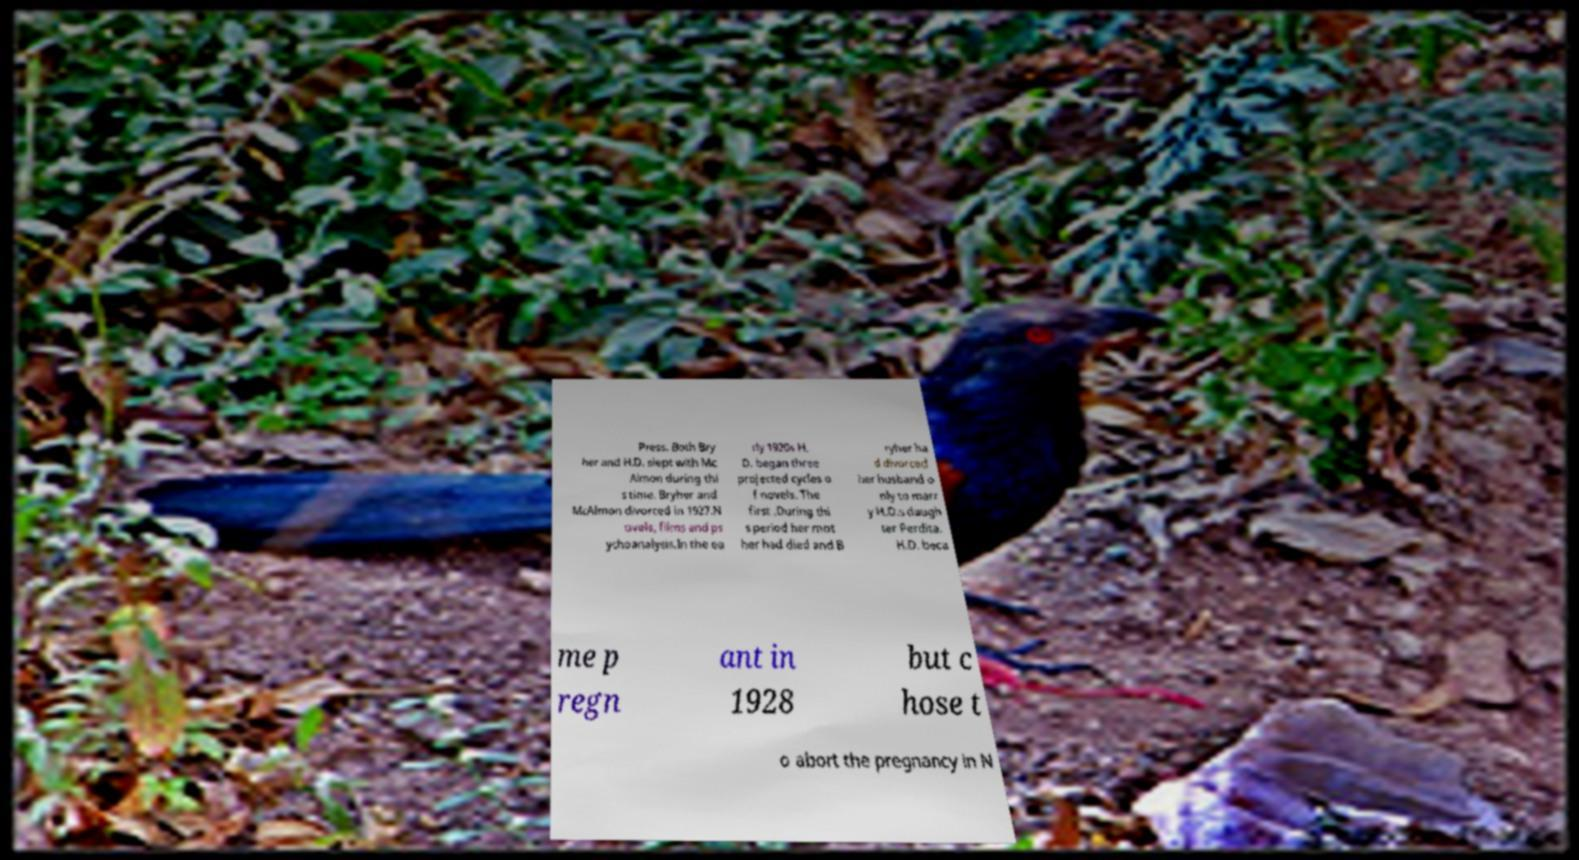Can you read and provide the text displayed in the image?This photo seems to have some interesting text. Can you extract and type it out for me? Press. Both Bry her and H.D. slept with Mc Almon during thi s time. Bryher and McAlmon divorced in 1927.N ovels, films and ps ychoanalysis.In the ea rly 1920s H. D. began three projected cycles o f novels. The first .During thi s period her mot her had died and B ryher ha d divorced her husband o nly to marr y H.D.s daugh ter Perdita. H.D. beca me p regn ant in 1928 but c hose t o abort the pregnancy in N 